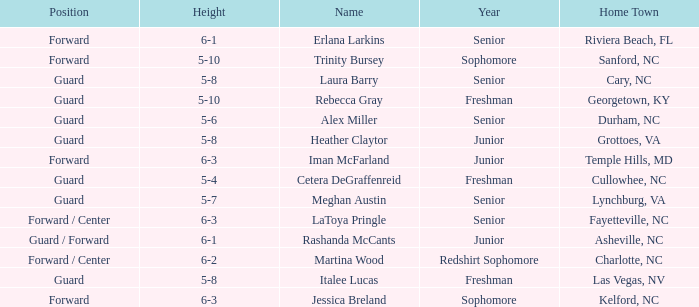In what year of school is the forward Iman McFarland? Junior. 